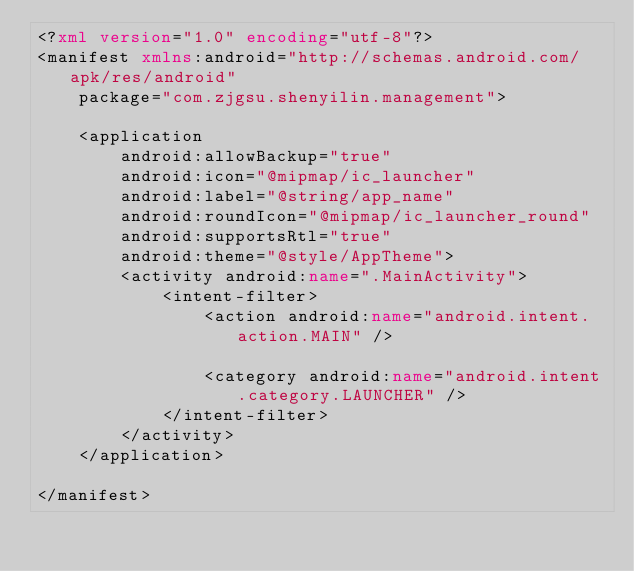<code> <loc_0><loc_0><loc_500><loc_500><_XML_><?xml version="1.0" encoding="utf-8"?>
<manifest xmlns:android="http://schemas.android.com/apk/res/android"
    package="com.zjgsu.shenyilin.management">

    <application
        android:allowBackup="true"
        android:icon="@mipmap/ic_launcher"
        android:label="@string/app_name"
        android:roundIcon="@mipmap/ic_launcher_round"
        android:supportsRtl="true"
        android:theme="@style/AppTheme">
        <activity android:name=".MainActivity">
            <intent-filter>
                <action android:name="android.intent.action.MAIN" />

                <category android:name="android.intent.category.LAUNCHER" />
            </intent-filter>
        </activity>
    </application>

</manifest></code> 